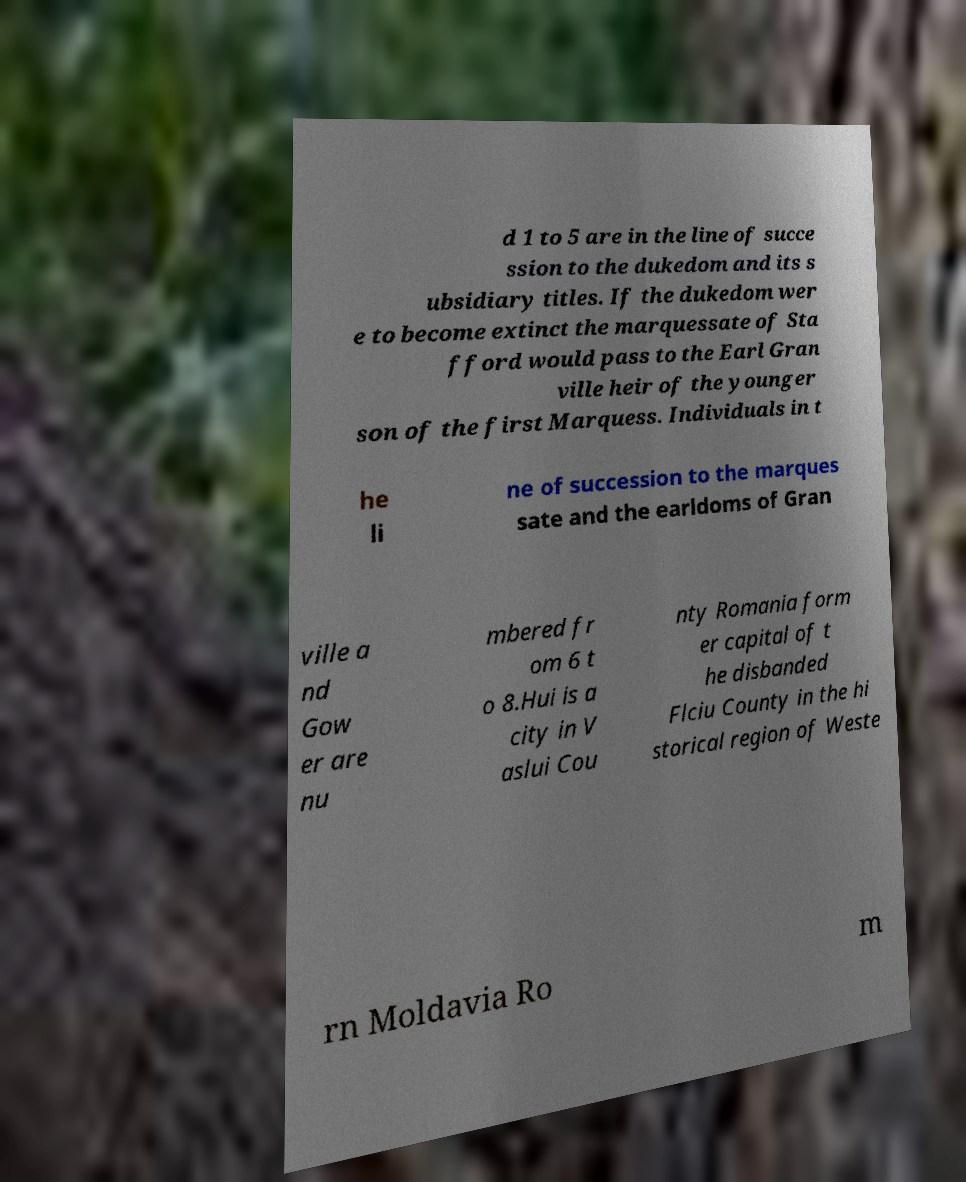There's text embedded in this image that I need extracted. Can you transcribe it verbatim? d 1 to 5 are in the line of succe ssion to the dukedom and its s ubsidiary titles. If the dukedom wer e to become extinct the marquessate of Sta fford would pass to the Earl Gran ville heir of the younger son of the first Marquess. Individuals in t he li ne of succession to the marques sate and the earldoms of Gran ville a nd Gow er are nu mbered fr om 6 t o 8.Hui is a city in V aslui Cou nty Romania form er capital of t he disbanded Flciu County in the hi storical region of Weste rn Moldavia Ro m 